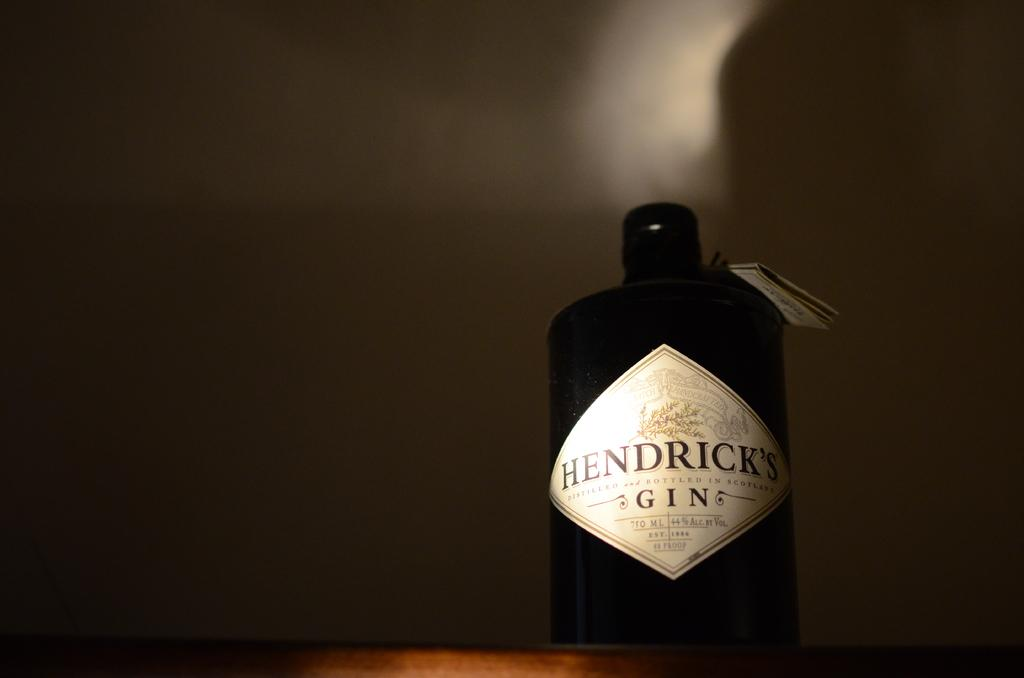<image>
Offer a succinct explanation of the picture presented. A 750 ml bottle of Hendrick's gin is 44% alcohol. 